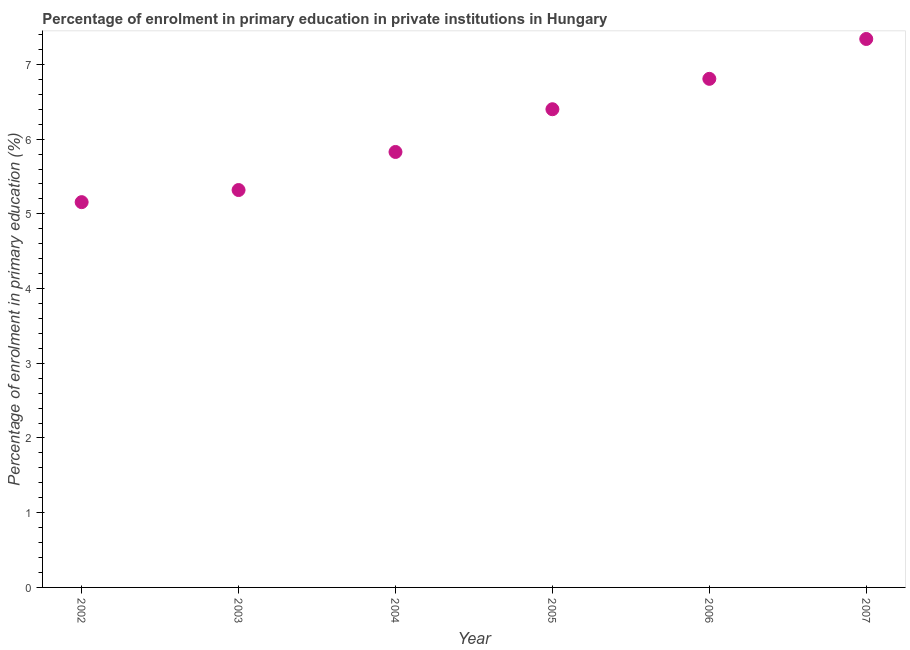What is the enrolment percentage in primary education in 2005?
Make the answer very short. 6.4. Across all years, what is the maximum enrolment percentage in primary education?
Make the answer very short. 7.34. Across all years, what is the minimum enrolment percentage in primary education?
Provide a succinct answer. 5.16. In which year was the enrolment percentage in primary education minimum?
Keep it short and to the point. 2002. What is the sum of the enrolment percentage in primary education?
Your answer should be very brief. 36.85. What is the difference between the enrolment percentage in primary education in 2003 and 2004?
Offer a very short reply. -0.51. What is the average enrolment percentage in primary education per year?
Make the answer very short. 6.14. What is the median enrolment percentage in primary education?
Your response must be concise. 6.11. What is the ratio of the enrolment percentage in primary education in 2002 to that in 2003?
Give a very brief answer. 0.97. Is the enrolment percentage in primary education in 2002 less than that in 2004?
Ensure brevity in your answer.  Yes. What is the difference between the highest and the second highest enrolment percentage in primary education?
Ensure brevity in your answer.  0.53. Is the sum of the enrolment percentage in primary education in 2004 and 2005 greater than the maximum enrolment percentage in primary education across all years?
Your answer should be very brief. Yes. What is the difference between the highest and the lowest enrolment percentage in primary education?
Give a very brief answer. 2.18. In how many years, is the enrolment percentage in primary education greater than the average enrolment percentage in primary education taken over all years?
Your answer should be compact. 3. What is the difference between two consecutive major ticks on the Y-axis?
Make the answer very short. 1. Are the values on the major ticks of Y-axis written in scientific E-notation?
Offer a terse response. No. Does the graph contain grids?
Your answer should be compact. No. What is the title of the graph?
Offer a terse response. Percentage of enrolment in primary education in private institutions in Hungary. What is the label or title of the X-axis?
Your answer should be very brief. Year. What is the label or title of the Y-axis?
Make the answer very short. Percentage of enrolment in primary education (%). What is the Percentage of enrolment in primary education (%) in 2002?
Offer a very short reply. 5.16. What is the Percentage of enrolment in primary education (%) in 2003?
Provide a succinct answer. 5.32. What is the Percentage of enrolment in primary education (%) in 2004?
Offer a terse response. 5.83. What is the Percentage of enrolment in primary education (%) in 2005?
Offer a very short reply. 6.4. What is the Percentage of enrolment in primary education (%) in 2006?
Provide a short and direct response. 6.81. What is the Percentage of enrolment in primary education (%) in 2007?
Provide a succinct answer. 7.34. What is the difference between the Percentage of enrolment in primary education (%) in 2002 and 2003?
Your answer should be very brief. -0.16. What is the difference between the Percentage of enrolment in primary education (%) in 2002 and 2004?
Your answer should be very brief. -0.67. What is the difference between the Percentage of enrolment in primary education (%) in 2002 and 2005?
Offer a very short reply. -1.24. What is the difference between the Percentage of enrolment in primary education (%) in 2002 and 2006?
Provide a short and direct response. -1.65. What is the difference between the Percentage of enrolment in primary education (%) in 2002 and 2007?
Your response must be concise. -2.18. What is the difference between the Percentage of enrolment in primary education (%) in 2003 and 2004?
Your answer should be compact. -0.51. What is the difference between the Percentage of enrolment in primary education (%) in 2003 and 2005?
Offer a very short reply. -1.08. What is the difference between the Percentage of enrolment in primary education (%) in 2003 and 2006?
Provide a succinct answer. -1.49. What is the difference between the Percentage of enrolment in primary education (%) in 2003 and 2007?
Provide a succinct answer. -2.02. What is the difference between the Percentage of enrolment in primary education (%) in 2004 and 2005?
Give a very brief answer. -0.57. What is the difference between the Percentage of enrolment in primary education (%) in 2004 and 2006?
Your answer should be very brief. -0.98. What is the difference between the Percentage of enrolment in primary education (%) in 2004 and 2007?
Ensure brevity in your answer.  -1.51. What is the difference between the Percentage of enrolment in primary education (%) in 2005 and 2006?
Your answer should be compact. -0.41. What is the difference between the Percentage of enrolment in primary education (%) in 2005 and 2007?
Your answer should be compact. -0.94. What is the difference between the Percentage of enrolment in primary education (%) in 2006 and 2007?
Offer a very short reply. -0.53. What is the ratio of the Percentage of enrolment in primary education (%) in 2002 to that in 2003?
Provide a succinct answer. 0.97. What is the ratio of the Percentage of enrolment in primary education (%) in 2002 to that in 2004?
Your response must be concise. 0.89. What is the ratio of the Percentage of enrolment in primary education (%) in 2002 to that in 2005?
Provide a short and direct response. 0.81. What is the ratio of the Percentage of enrolment in primary education (%) in 2002 to that in 2006?
Provide a short and direct response. 0.76. What is the ratio of the Percentage of enrolment in primary education (%) in 2002 to that in 2007?
Your answer should be compact. 0.7. What is the ratio of the Percentage of enrolment in primary education (%) in 2003 to that in 2005?
Offer a terse response. 0.83. What is the ratio of the Percentage of enrolment in primary education (%) in 2003 to that in 2006?
Provide a short and direct response. 0.78. What is the ratio of the Percentage of enrolment in primary education (%) in 2003 to that in 2007?
Offer a terse response. 0.72. What is the ratio of the Percentage of enrolment in primary education (%) in 2004 to that in 2005?
Give a very brief answer. 0.91. What is the ratio of the Percentage of enrolment in primary education (%) in 2004 to that in 2006?
Ensure brevity in your answer.  0.86. What is the ratio of the Percentage of enrolment in primary education (%) in 2004 to that in 2007?
Give a very brief answer. 0.79. What is the ratio of the Percentage of enrolment in primary education (%) in 2005 to that in 2007?
Offer a very short reply. 0.87. What is the ratio of the Percentage of enrolment in primary education (%) in 2006 to that in 2007?
Provide a succinct answer. 0.93. 